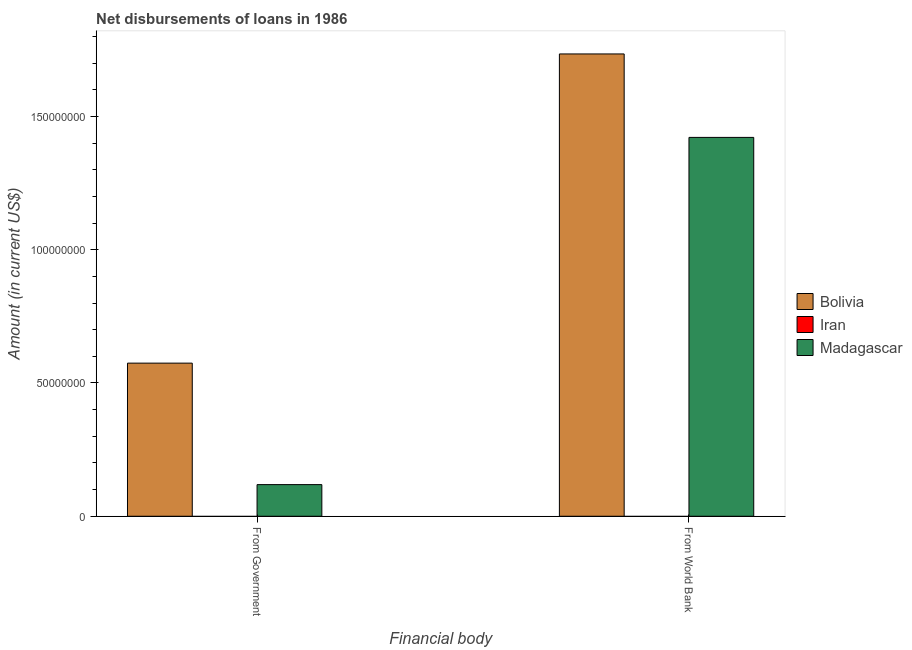How many different coloured bars are there?
Make the answer very short. 2. How many groups of bars are there?
Make the answer very short. 2. Are the number of bars on each tick of the X-axis equal?
Offer a very short reply. Yes. How many bars are there on the 2nd tick from the right?
Offer a terse response. 2. What is the label of the 1st group of bars from the left?
Provide a short and direct response. From Government. What is the net disbursements of loan from government in Iran?
Ensure brevity in your answer.  0. Across all countries, what is the maximum net disbursements of loan from government?
Your answer should be very brief. 5.74e+07. Across all countries, what is the minimum net disbursements of loan from government?
Provide a short and direct response. 0. In which country was the net disbursements of loan from government maximum?
Make the answer very short. Bolivia. What is the total net disbursements of loan from world bank in the graph?
Offer a terse response. 3.16e+08. What is the difference between the net disbursements of loan from world bank in Bolivia and that in Madagascar?
Keep it short and to the point. 3.13e+07. What is the difference between the net disbursements of loan from world bank in Iran and the net disbursements of loan from government in Bolivia?
Your answer should be compact. -5.74e+07. What is the average net disbursements of loan from government per country?
Your response must be concise. 2.31e+07. What is the difference between the net disbursements of loan from world bank and net disbursements of loan from government in Madagascar?
Make the answer very short. 1.30e+08. In how many countries, is the net disbursements of loan from world bank greater than 90000000 US$?
Give a very brief answer. 2. What is the ratio of the net disbursements of loan from world bank in Bolivia to that in Madagascar?
Offer a very short reply. 1.22. In how many countries, is the net disbursements of loan from world bank greater than the average net disbursements of loan from world bank taken over all countries?
Give a very brief answer. 2. How many bars are there?
Make the answer very short. 4. Are all the bars in the graph horizontal?
Offer a very short reply. No. How are the legend labels stacked?
Give a very brief answer. Vertical. What is the title of the graph?
Keep it short and to the point. Net disbursements of loans in 1986. Does "Latin America(all income levels)" appear as one of the legend labels in the graph?
Ensure brevity in your answer.  No. What is the label or title of the X-axis?
Ensure brevity in your answer.  Financial body. What is the Amount (in current US$) in Bolivia in From Government?
Keep it short and to the point. 5.74e+07. What is the Amount (in current US$) of Iran in From Government?
Your answer should be very brief. 0. What is the Amount (in current US$) of Madagascar in From Government?
Ensure brevity in your answer.  1.19e+07. What is the Amount (in current US$) in Bolivia in From World Bank?
Provide a short and direct response. 1.73e+08. What is the Amount (in current US$) in Madagascar in From World Bank?
Provide a short and direct response. 1.42e+08. Across all Financial body, what is the maximum Amount (in current US$) of Bolivia?
Your answer should be very brief. 1.73e+08. Across all Financial body, what is the maximum Amount (in current US$) of Madagascar?
Keep it short and to the point. 1.42e+08. Across all Financial body, what is the minimum Amount (in current US$) of Bolivia?
Your answer should be very brief. 5.74e+07. Across all Financial body, what is the minimum Amount (in current US$) of Madagascar?
Offer a terse response. 1.19e+07. What is the total Amount (in current US$) in Bolivia in the graph?
Make the answer very short. 2.31e+08. What is the total Amount (in current US$) in Madagascar in the graph?
Your response must be concise. 1.54e+08. What is the difference between the Amount (in current US$) in Bolivia in From Government and that in From World Bank?
Provide a succinct answer. -1.16e+08. What is the difference between the Amount (in current US$) of Madagascar in From Government and that in From World Bank?
Ensure brevity in your answer.  -1.30e+08. What is the difference between the Amount (in current US$) of Bolivia in From Government and the Amount (in current US$) of Madagascar in From World Bank?
Your answer should be compact. -8.47e+07. What is the average Amount (in current US$) in Bolivia per Financial body?
Make the answer very short. 1.15e+08. What is the average Amount (in current US$) of Iran per Financial body?
Make the answer very short. 0. What is the average Amount (in current US$) in Madagascar per Financial body?
Provide a short and direct response. 7.70e+07. What is the difference between the Amount (in current US$) in Bolivia and Amount (in current US$) in Madagascar in From Government?
Provide a succinct answer. 4.56e+07. What is the difference between the Amount (in current US$) in Bolivia and Amount (in current US$) in Madagascar in From World Bank?
Your answer should be compact. 3.13e+07. What is the ratio of the Amount (in current US$) of Bolivia in From Government to that in From World Bank?
Your answer should be compact. 0.33. What is the ratio of the Amount (in current US$) of Madagascar in From Government to that in From World Bank?
Ensure brevity in your answer.  0.08. What is the difference between the highest and the second highest Amount (in current US$) of Bolivia?
Give a very brief answer. 1.16e+08. What is the difference between the highest and the second highest Amount (in current US$) of Madagascar?
Provide a short and direct response. 1.30e+08. What is the difference between the highest and the lowest Amount (in current US$) of Bolivia?
Keep it short and to the point. 1.16e+08. What is the difference between the highest and the lowest Amount (in current US$) in Madagascar?
Your answer should be very brief. 1.30e+08. 